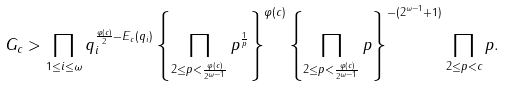Convert formula to latex. <formula><loc_0><loc_0><loc_500><loc_500>G _ { c } > \prod _ { 1 \leq i \leq \omega } q _ { i } ^ { \frac { \varphi ( c ) } { 2 } - E _ { c } ( q _ { i } ) } \left \{ \prod _ { 2 \leq p < \frac { \varphi ( c ) } { 2 ^ { \omega - 1 } } } p ^ { \frac { 1 } { p } } \right \} ^ { \varphi ( c ) } \left \{ \prod _ { 2 \leq p < \frac { \varphi ( c ) } { 2 ^ { \omega - 1 } } } p \right \} ^ { - ( 2 ^ { \omega - 1 } + 1 ) } \prod _ { 2 \leq p < c } p .</formula> 